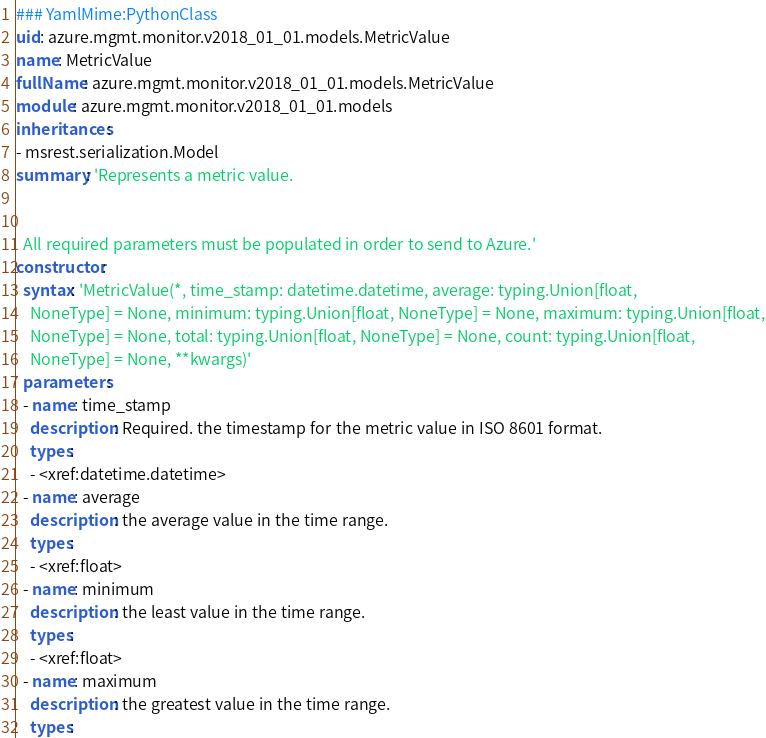Convert code to text. <code><loc_0><loc_0><loc_500><loc_500><_YAML_>### YamlMime:PythonClass
uid: azure.mgmt.monitor.v2018_01_01.models.MetricValue
name: MetricValue
fullName: azure.mgmt.monitor.v2018_01_01.models.MetricValue
module: azure.mgmt.monitor.v2018_01_01.models
inheritances:
- msrest.serialization.Model
summary: 'Represents a metric value.


  All required parameters must be populated in order to send to Azure.'
constructor:
  syntax: 'MetricValue(*, time_stamp: datetime.datetime, average: typing.Union[float,
    NoneType] = None, minimum: typing.Union[float, NoneType] = None, maximum: typing.Union[float,
    NoneType] = None, total: typing.Union[float, NoneType] = None, count: typing.Union[float,
    NoneType] = None, **kwargs)'
  parameters:
  - name: time_stamp
    description: Required. the timestamp for the metric value in ISO 8601 format.
    types:
    - <xref:datetime.datetime>
  - name: average
    description: the average value in the time range.
    types:
    - <xref:float>
  - name: minimum
    description: the least value in the time range.
    types:
    - <xref:float>
  - name: maximum
    description: the greatest value in the time range.
    types:</code> 